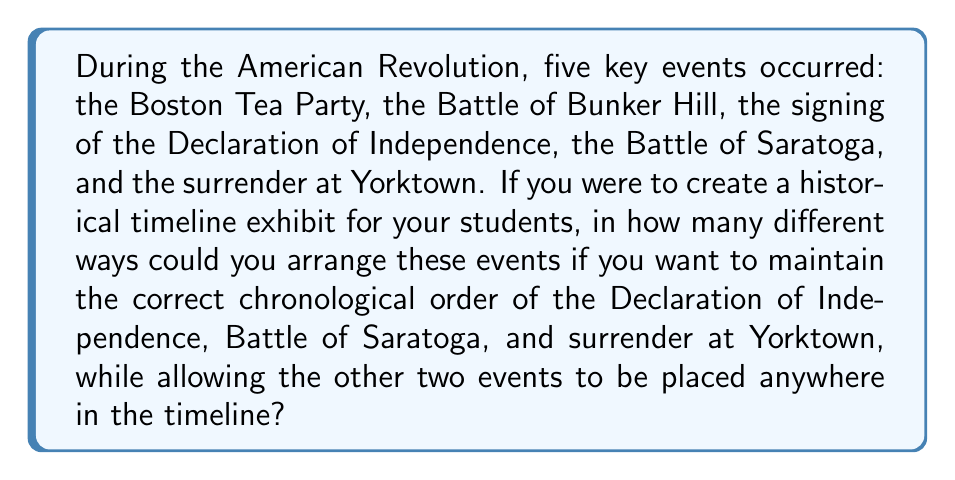Could you help me with this problem? Let's approach this step-by-step:

1) First, we need to recognize that this is a permutation problem with some constraints.

2) We have 5 events in total, but 3 of them (Declaration of Independence, Battle of Saratoga, and surrender at Yorktown) must maintain their relative order.

3) We can consider these 3 events as a single unit, reducing our problem to arranging 3 items: the unit of 3 fixed-order events, and the other 2 individual events.

4) The number of ways to arrange 3 items is simply $3! = 3 \times 2 \times 1 = 6$.

5) However, we're not done yet. For each of these 6 arrangements, we need to consider the ways we can insert the other 2 events (Boston Tea Party and Battle of Bunker Hill) within the unit of 3 fixed-order events.

6) The unit of 3 fixed-order events creates 4 possible positions for inserting the other events:
   - Before the Declaration of Independence
   - Between Declaration of Independence and Battle of Saratoga
   - Between Battle of Saratoga and surrender at Yorktown
   - After the surrender at Yorktown

7) This is a combination problem. We need to choose 2 positions out of these 4 to place our 2 events. This can be calculated using the combination formula:

   $$\binom{4}{2} = \frac{4!}{2!(4-2)!} = \frac{4 \times 3}{2 \times 1} = 6$$

8) By the multiplication principle, the total number of possible arrangements is:

   $6 \times 6 = 36$

Therefore, there are 36 different ways to arrange these events under the given constraints.
Answer: 36 ways 